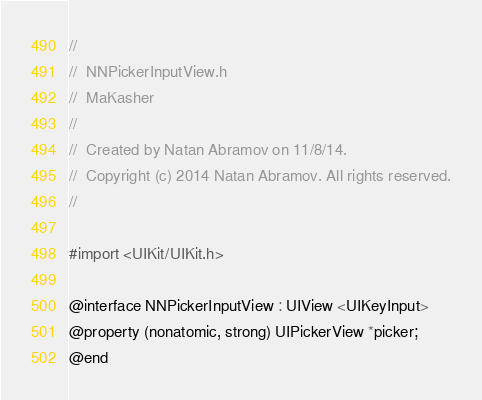Convert code to text. <code><loc_0><loc_0><loc_500><loc_500><_C_>//
//  NNPickerInputView.h
//  MaKasher
//
//  Created by Natan Abramov on 11/8/14.
//  Copyright (c) 2014 Natan Abramov. All rights reserved.
//

#import <UIKit/UIKit.h>

@interface NNPickerInputView : UIView <UIKeyInput>
@property (nonatomic, strong) UIPickerView *picker;
@end
</code> 